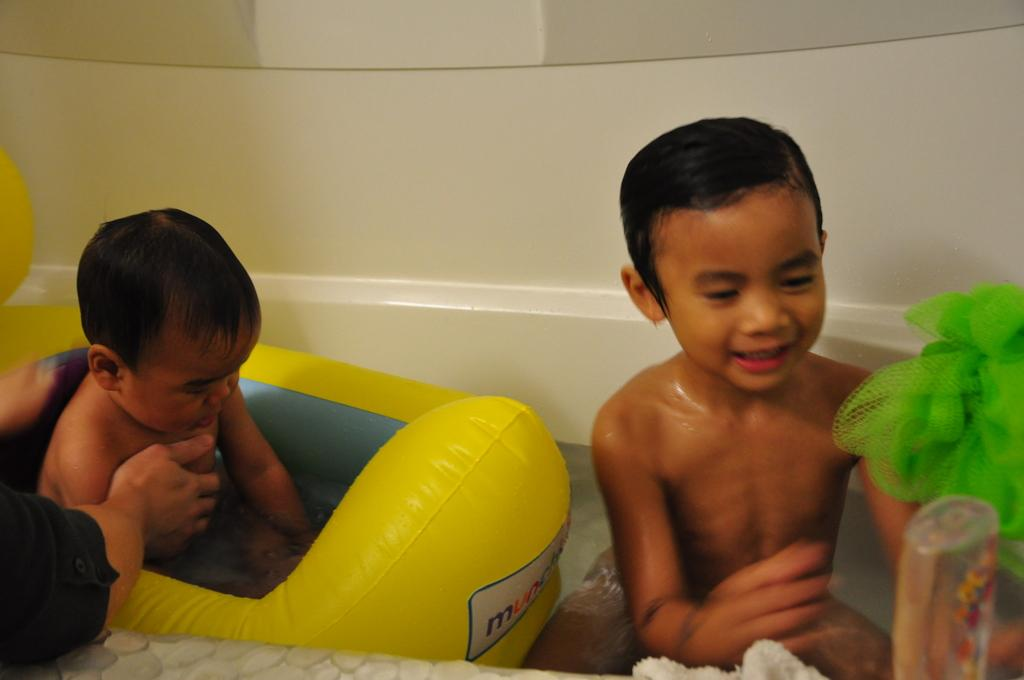What is the boy doing in the image? The boy is sitting in an air balloon. What is inside the air balloon with the boy? There is water in the air balloon. What can be seen on the right side of the image? There is a kid on the right side of the image. Can you describe any other elements visible in the image? There are additional unspecified things visible in the image. What type of brass instrument is the boy playing in the air balloon? There is no brass instrument present in the image; the boy is sitting in an air balloon with water. How does the bat help the boy navigate the air balloon? There is no bat present in the image, and the boy is not navigating the air balloon; he is simply sitting in it. 